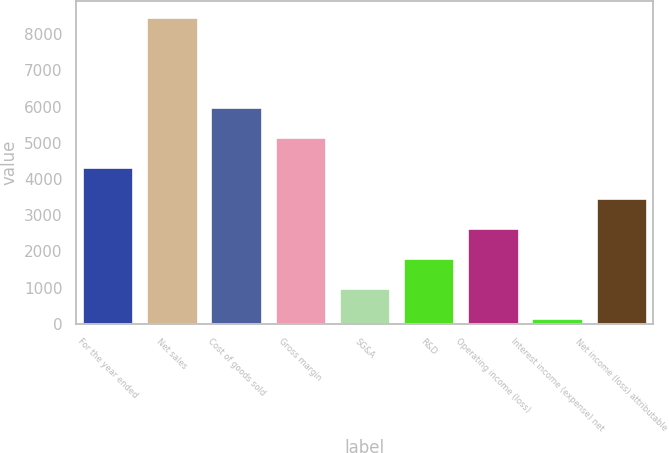Convert chart to OTSL. <chart><loc_0><loc_0><loc_500><loc_500><bar_chart><fcel>For the year ended<fcel>Net sales<fcel>Cost of goods sold<fcel>Gross margin<fcel>SG&A<fcel>R&D<fcel>Operating income (loss)<fcel>Interest income (expense) net<fcel>Net income (loss) attributable<nl><fcel>4321<fcel>8482<fcel>5985.4<fcel>5153.2<fcel>992.2<fcel>1824.4<fcel>2656.6<fcel>160<fcel>3488.8<nl></chart> 